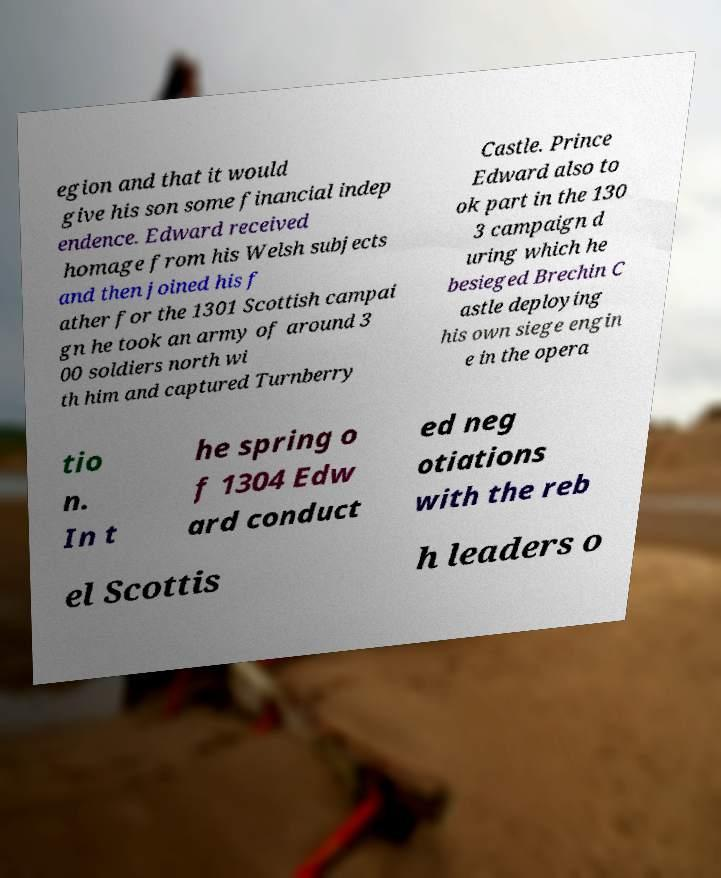For documentation purposes, I need the text within this image transcribed. Could you provide that? egion and that it would give his son some financial indep endence. Edward received homage from his Welsh subjects and then joined his f ather for the 1301 Scottish campai gn he took an army of around 3 00 soldiers north wi th him and captured Turnberry Castle. Prince Edward also to ok part in the 130 3 campaign d uring which he besieged Brechin C astle deploying his own siege engin e in the opera tio n. In t he spring o f 1304 Edw ard conduct ed neg otiations with the reb el Scottis h leaders o 